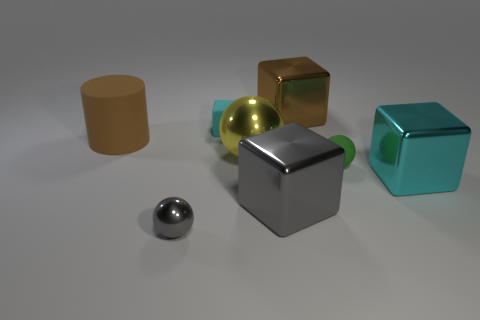Add 1 large metallic cubes. How many objects exist? 9 Subtract all cylinders. How many objects are left? 7 Subtract all large brown things. Subtract all tiny rubber cubes. How many objects are left? 5 Add 8 big yellow metal things. How many big yellow metal things are left? 9 Add 8 large brown rubber objects. How many large brown rubber objects exist? 9 Subtract 0 cyan cylinders. How many objects are left? 8 